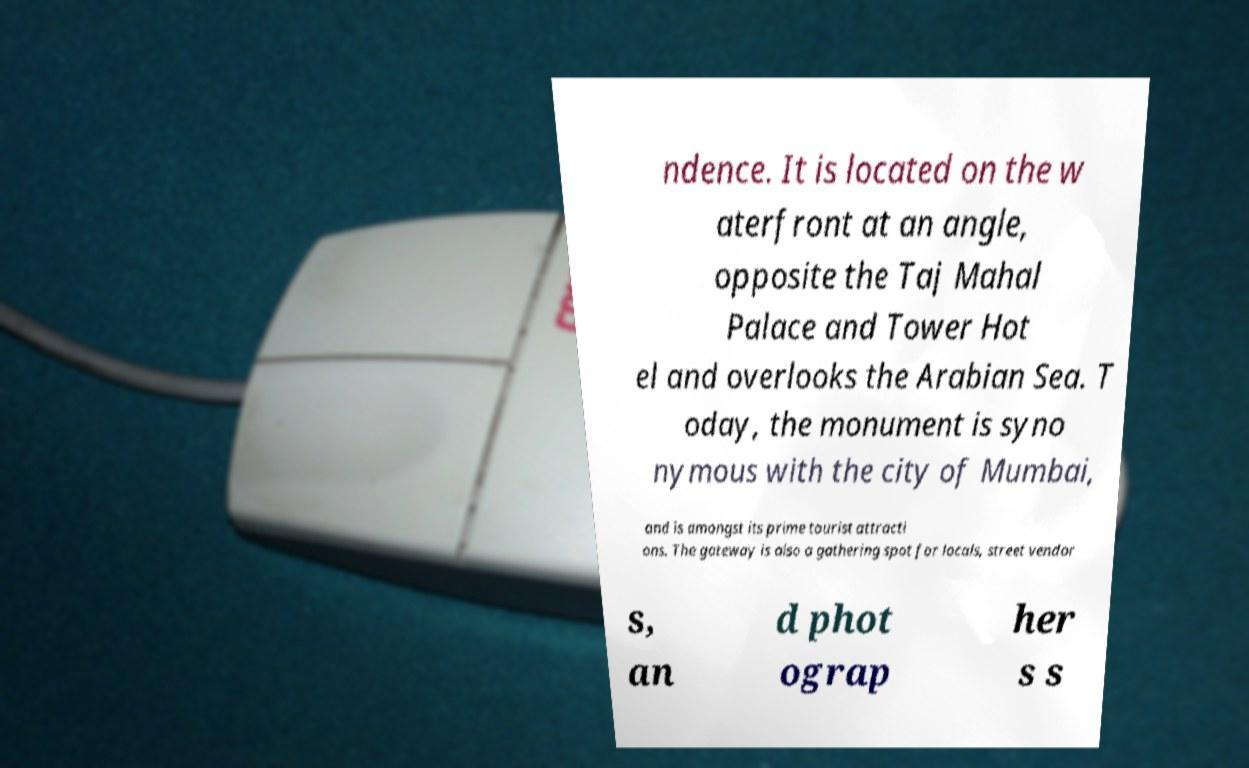Could you assist in decoding the text presented in this image and type it out clearly? ndence. It is located on the w aterfront at an angle, opposite the Taj Mahal Palace and Tower Hot el and overlooks the Arabian Sea. T oday, the monument is syno nymous with the city of Mumbai, and is amongst its prime tourist attracti ons. The gateway is also a gathering spot for locals, street vendor s, an d phot ograp her s s 